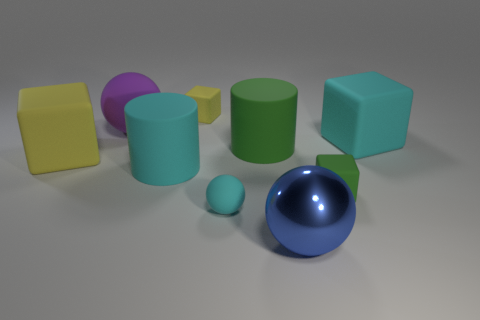Subtract 1 cubes. How many cubes are left? 3 Add 1 large red metal objects. How many objects exist? 10 Subtract all balls. How many objects are left? 6 Subtract 0 purple cylinders. How many objects are left? 9 Subtract all tiny red spheres. Subtract all big cyan cylinders. How many objects are left? 8 Add 4 big cylinders. How many big cylinders are left? 6 Add 3 tiny green cylinders. How many tiny green cylinders exist? 3 